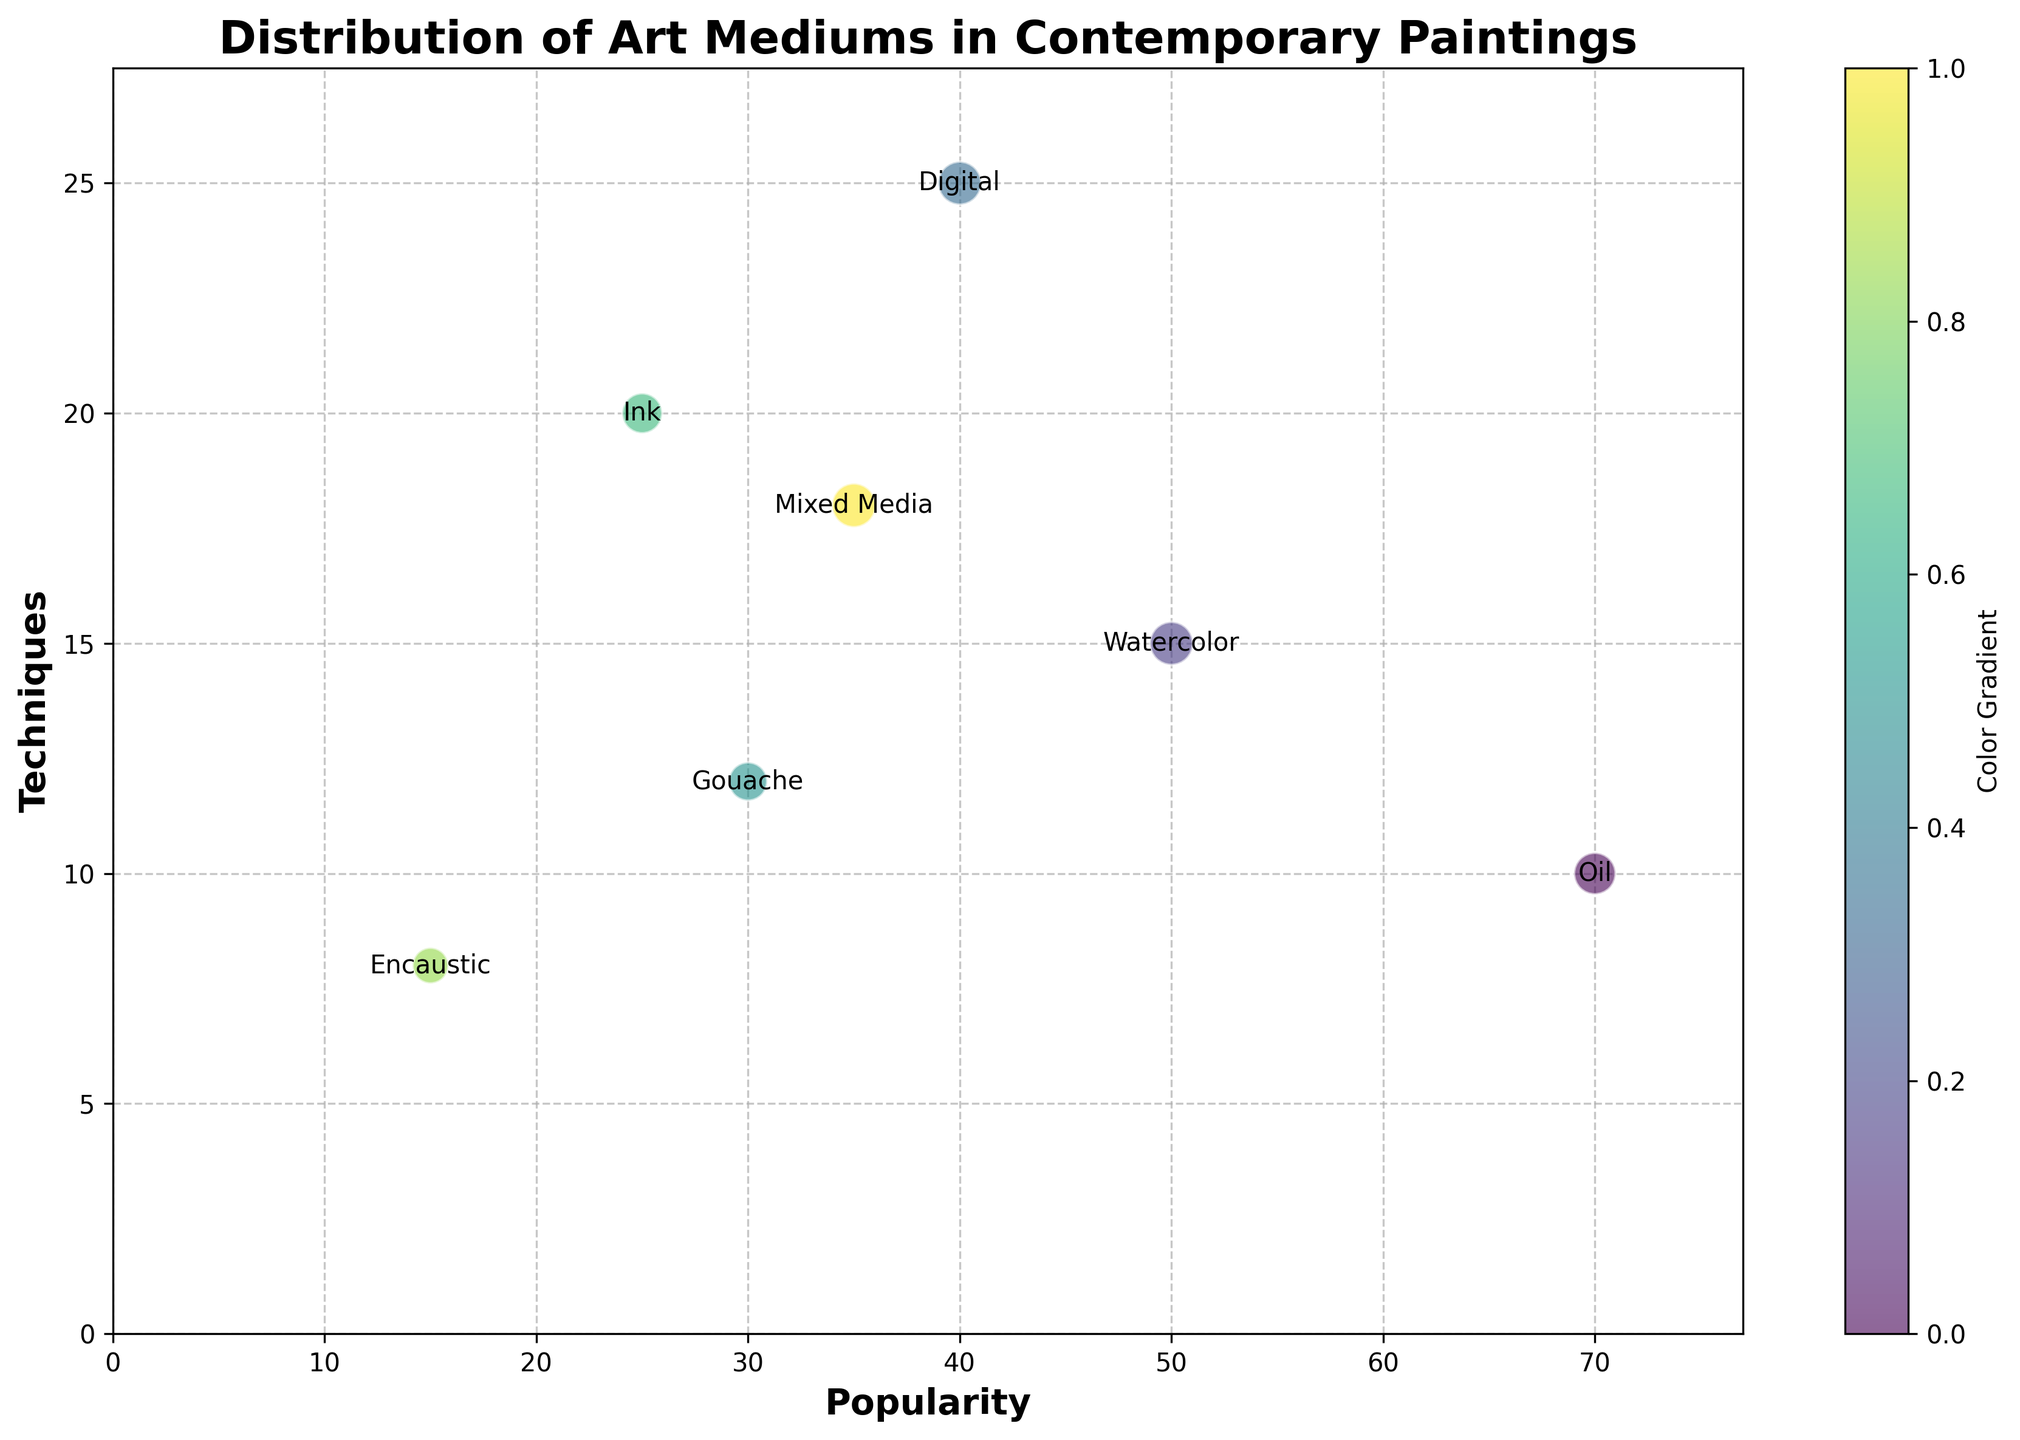What is the title of the chart? The title is usually located at the top of the chart and provides a summary of the data being depicted. The title helps to understand the context of what is being displayed. The chart's title is "Distribution of Art Mediums in Contemporary Paintings".
Answer: Distribution of Art Mediums in Contemporary Paintings What are the labels on the x and y axes? The x and y axis labels offer essential information about the variables being measured. The x-axis label indicates "Popularity," and the y-axis label indicates "Techniques," which help to understand the dimensions being analyzed for each art medium.
Answer: Popularity and Techniques Which art medium has the largest bubble? To identify the largest bubble, look for the bubble with the biggest size, which is an indicator of the "DescriptionSize" data point. The 'Watercolor' medium has the largest bubble.
Answer: Watercolor Which art medium has the highest popularity? To find the highest popularity, look for the bubble furthest to the right on the x-axis, as it represents the "Popularity" measure. 'Oil' has the highest popularity, as it is positioned at 70 on the x-axis.
Answer: Oil Which art medium has the most techniques? To determine the medium with the most techniques, locate the bubble that is highest on the y-axis since it represents the "Techniques" measure. 'Digital' has the most techniques, marked at 25 on the y-axis.
Answer: Digital What is the average popularity of the art mediums? Calculate the average by summing the popularity values and dividing by the number of art mediums. The sum of the popularity (70 + 50 + 40 + 30 + 25 + 15 + 35) is 265, and there are 7 data points, so 265/7 ≈ 37.86.
Answer: 37.86 Which art medium has both popularity and techniques closest to the median values of those attributes? First, find the median values of popularity and techniques. The ordered popularity values are [15, 25, 30, 35, 40, 50, 70], median is 35, and the ordered techniques values are [8, 10, 12, 15, 18, 20, 25], median is 15. 'Mixed Media' (Popularity=35, Techniques=18) is closest to both medians.
Answer: Mixed Media How does the description size compare between 'Oil' and 'Mixed Media'? Compare the sizes of the bubbles for 'Oil' and 'Mixed Media'. The size of the bubble for 'Oil' (9 characters) is smaller compared to 'Mixed Media' (18 characters). The visual comparison shows 'Mixed Media' has a larger bubble indicating a larger description size.
Answer: 'Mixed Media' has a larger description size Which color coding method is used to distinguish the bubbles? The colors of the bubbles follow a gradient that likely represents a continuous range mapped by the viridis colormap. The colors transition smoothly across the different points.
Answer: Color gradient 